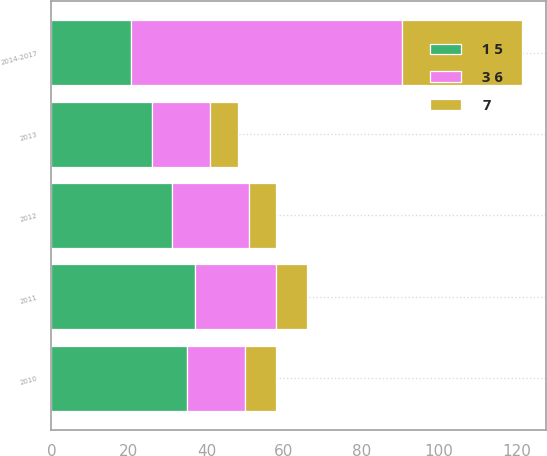<chart> <loc_0><loc_0><loc_500><loc_500><stacked_bar_chart><ecel><fcel>2010<fcel>2011<fcel>2012<fcel>2013<fcel>2014-2017<nl><fcel>1 5<fcel>35<fcel>37<fcel>31<fcel>26<fcel>20.5<nl><fcel>3 6<fcel>15<fcel>21<fcel>20<fcel>15<fcel>70<nl><fcel>7<fcel>8<fcel>8<fcel>7<fcel>7<fcel>31<nl></chart> 